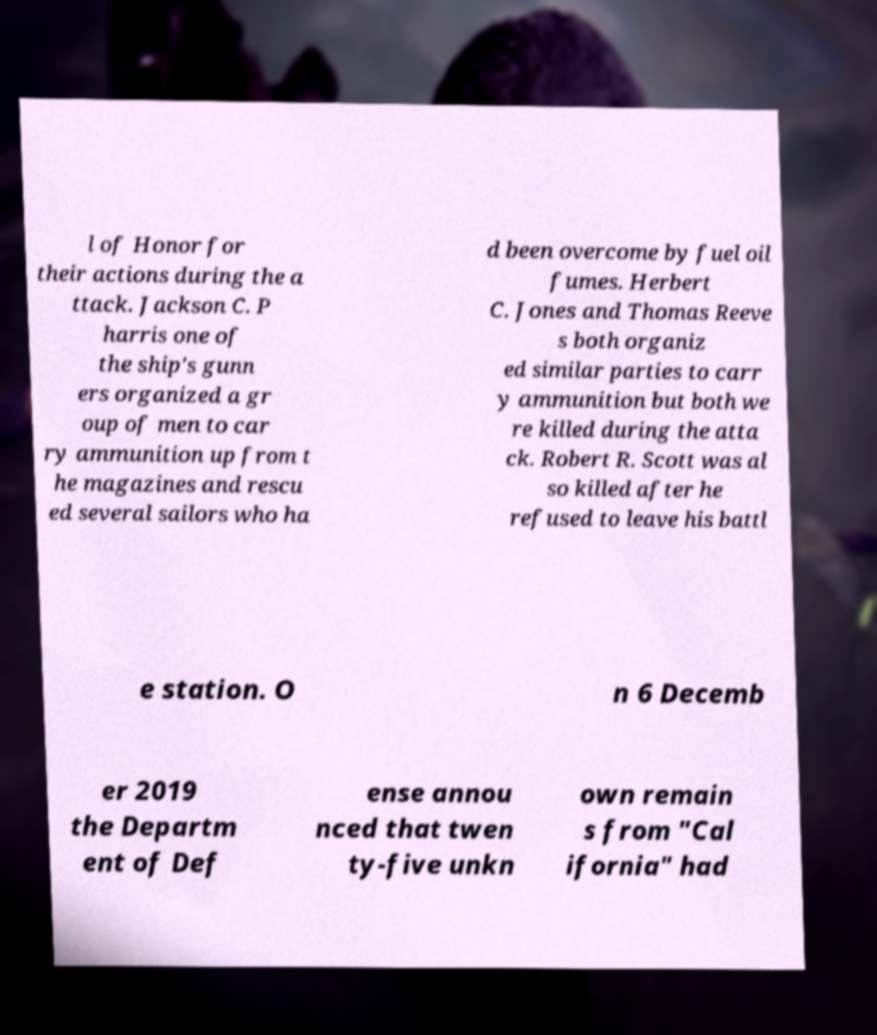Please identify and transcribe the text found in this image. l of Honor for their actions during the a ttack. Jackson C. P harris one of the ship's gunn ers organized a gr oup of men to car ry ammunition up from t he magazines and rescu ed several sailors who ha d been overcome by fuel oil fumes. Herbert C. Jones and Thomas Reeve s both organiz ed similar parties to carr y ammunition but both we re killed during the atta ck. Robert R. Scott was al so killed after he refused to leave his battl e station. O n 6 Decemb er 2019 the Departm ent of Def ense annou nced that twen ty-five unkn own remain s from "Cal ifornia" had 